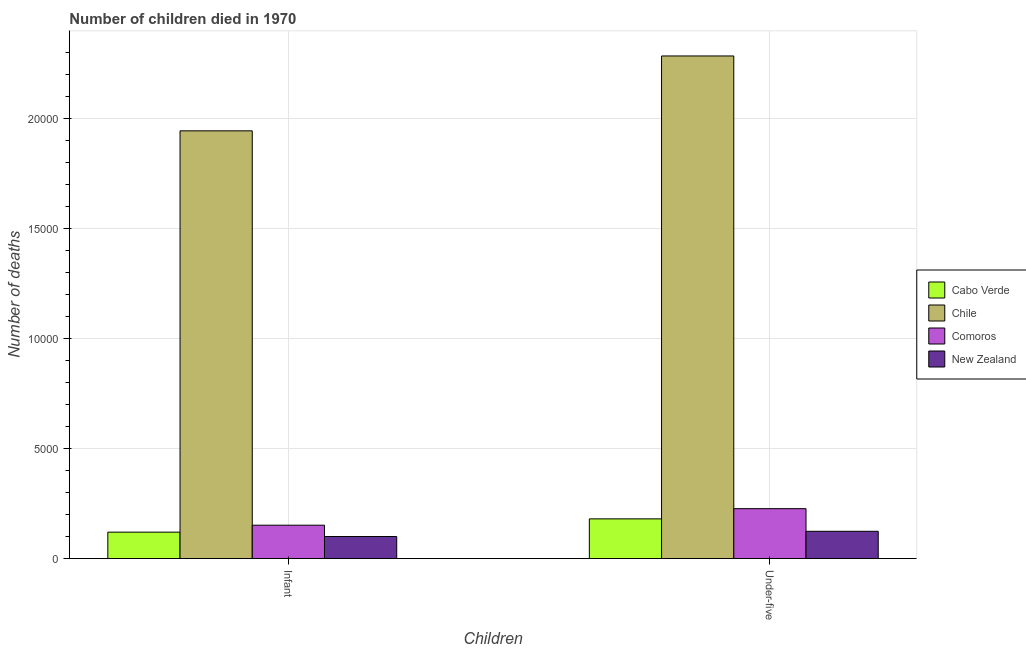How many different coloured bars are there?
Your answer should be very brief. 4. Are the number of bars per tick equal to the number of legend labels?
Make the answer very short. Yes. Are the number of bars on each tick of the X-axis equal?
Ensure brevity in your answer.  Yes. How many bars are there on the 2nd tick from the left?
Offer a very short reply. 4. What is the label of the 2nd group of bars from the left?
Your answer should be compact. Under-five. What is the number of under-five deaths in New Zealand?
Your answer should be compact. 1239. Across all countries, what is the maximum number of under-five deaths?
Your answer should be very brief. 2.28e+04. Across all countries, what is the minimum number of under-five deaths?
Your response must be concise. 1239. In which country was the number of under-five deaths minimum?
Offer a very short reply. New Zealand. What is the total number of under-five deaths in the graph?
Your response must be concise. 2.81e+04. What is the difference between the number of under-five deaths in Cabo Verde and that in Chile?
Make the answer very short. -2.10e+04. What is the difference between the number of under-five deaths in Cabo Verde and the number of infant deaths in Chile?
Your response must be concise. -1.76e+04. What is the average number of under-five deaths per country?
Your answer should be compact. 7034.75. What is the difference between the number of infant deaths and number of under-five deaths in Cabo Verde?
Your answer should be compact. -603. In how many countries, is the number of infant deaths greater than 8000 ?
Your response must be concise. 1. What is the ratio of the number of under-five deaths in Chile to that in Cabo Verde?
Give a very brief answer. 12.66. Is the number of under-five deaths in Chile less than that in Comoros?
Make the answer very short. No. What does the 4th bar from the left in Under-five represents?
Offer a very short reply. New Zealand. What does the 1st bar from the right in Infant represents?
Ensure brevity in your answer.  New Zealand. Are all the bars in the graph horizontal?
Offer a very short reply. No. How many countries are there in the graph?
Offer a terse response. 4. Are the values on the major ticks of Y-axis written in scientific E-notation?
Give a very brief answer. No. Does the graph contain any zero values?
Your response must be concise. No. Does the graph contain grids?
Give a very brief answer. Yes. How are the legend labels stacked?
Provide a succinct answer. Vertical. What is the title of the graph?
Keep it short and to the point. Number of children died in 1970. Does "French Polynesia" appear as one of the legend labels in the graph?
Offer a terse response. No. What is the label or title of the X-axis?
Offer a terse response. Children. What is the label or title of the Y-axis?
Make the answer very short. Number of deaths. What is the Number of deaths in Cabo Verde in Infant?
Make the answer very short. 1200. What is the Number of deaths in Chile in Infant?
Your answer should be very brief. 1.94e+04. What is the Number of deaths in Comoros in Infant?
Offer a terse response. 1516. What is the Number of deaths of New Zealand in Infant?
Offer a very short reply. 1002. What is the Number of deaths of Cabo Verde in Under-five?
Your answer should be compact. 1803. What is the Number of deaths in Chile in Under-five?
Make the answer very short. 2.28e+04. What is the Number of deaths of Comoros in Under-five?
Offer a very short reply. 2267. What is the Number of deaths of New Zealand in Under-five?
Your answer should be very brief. 1239. Across all Children, what is the maximum Number of deaths of Cabo Verde?
Offer a terse response. 1803. Across all Children, what is the maximum Number of deaths in Chile?
Your answer should be very brief. 2.28e+04. Across all Children, what is the maximum Number of deaths of Comoros?
Offer a very short reply. 2267. Across all Children, what is the maximum Number of deaths of New Zealand?
Your answer should be very brief. 1239. Across all Children, what is the minimum Number of deaths in Cabo Verde?
Make the answer very short. 1200. Across all Children, what is the minimum Number of deaths of Chile?
Your answer should be compact. 1.94e+04. Across all Children, what is the minimum Number of deaths in Comoros?
Ensure brevity in your answer.  1516. Across all Children, what is the minimum Number of deaths of New Zealand?
Offer a very short reply. 1002. What is the total Number of deaths in Cabo Verde in the graph?
Give a very brief answer. 3003. What is the total Number of deaths of Chile in the graph?
Offer a terse response. 4.23e+04. What is the total Number of deaths of Comoros in the graph?
Make the answer very short. 3783. What is the total Number of deaths of New Zealand in the graph?
Your response must be concise. 2241. What is the difference between the Number of deaths in Cabo Verde in Infant and that in Under-five?
Your answer should be compact. -603. What is the difference between the Number of deaths in Chile in Infant and that in Under-five?
Provide a succinct answer. -3401. What is the difference between the Number of deaths in Comoros in Infant and that in Under-five?
Offer a very short reply. -751. What is the difference between the Number of deaths of New Zealand in Infant and that in Under-five?
Ensure brevity in your answer.  -237. What is the difference between the Number of deaths in Cabo Verde in Infant and the Number of deaths in Chile in Under-five?
Offer a very short reply. -2.16e+04. What is the difference between the Number of deaths in Cabo Verde in Infant and the Number of deaths in Comoros in Under-five?
Give a very brief answer. -1067. What is the difference between the Number of deaths of Cabo Verde in Infant and the Number of deaths of New Zealand in Under-five?
Your response must be concise. -39. What is the difference between the Number of deaths of Chile in Infant and the Number of deaths of Comoros in Under-five?
Your response must be concise. 1.72e+04. What is the difference between the Number of deaths of Chile in Infant and the Number of deaths of New Zealand in Under-five?
Make the answer very short. 1.82e+04. What is the difference between the Number of deaths in Comoros in Infant and the Number of deaths in New Zealand in Under-five?
Keep it short and to the point. 277. What is the average Number of deaths of Cabo Verde per Children?
Keep it short and to the point. 1501.5. What is the average Number of deaths of Chile per Children?
Make the answer very short. 2.11e+04. What is the average Number of deaths of Comoros per Children?
Offer a very short reply. 1891.5. What is the average Number of deaths of New Zealand per Children?
Your answer should be very brief. 1120.5. What is the difference between the Number of deaths in Cabo Verde and Number of deaths in Chile in Infant?
Make the answer very short. -1.82e+04. What is the difference between the Number of deaths in Cabo Verde and Number of deaths in Comoros in Infant?
Keep it short and to the point. -316. What is the difference between the Number of deaths of Cabo Verde and Number of deaths of New Zealand in Infant?
Your answer should be compact. 198. What is the difference between the Number of deaths in Chile and Number of deaths in Comoros in Infant?
Your answer should be compact. 1.79e+04. What is the difference between the Number of deaths in Chile and Number of deaths in New Zealand in Infant?
Keep it short and to the point. 1.84e+04. What is the difference between the Number of deaths of Comoros and Number of deaths of New Zealand in Infant?
Your answer should be very brief. 514. What is the difference between the Number of deaths in Cabo Verde and Number of deaths in Chile in Under-five?
Your answer should be very brief. -2.10e+04. What is the difference between the Number of deaths in Cabo Verde and Number of deaths in Comoros in Under-five?
Offer a terse response. -464. What is the difference between the Number of deaths of Cabo Verde and Number of deaths of New Zealand in Under-five?
Ensure brevity in your answer.  564. What is the difference between the Number of deaths of Chile and Number of deaths of Comoros in Under-five?
Offer a terse response. 2.06e+04. What is the difference between the Number of deaths in Chile and Number of deaths in New Zealand in Under-five?
Keep it short and to the point. 2.16e+04. What is the difference between the Number of deaths of Comoros and Number of deaths of New Zealand in Under-five?
Provide a short and direct response. 1028. What is the ratio of the Number of deaths in Cabo Verde in Infant to that in Under-five?
Ensure brevity in your answer.  0.67. What is the ratio of the Number of deaths in Chile in Infant to that in Under-five?
Keep it short and to the point. 0.85. What is the ratio of the Number of deaths of Comoros in Infant to that in Under-five?
Your answer should be very brief. 0.67. What is the ratio of the Number of deaths in New Zealand in Infant to that in Under-five?
Offer a very short reply. 0.81. What is the difference between the highest and the second highest Number of deaths in Cabo Verde?
Give a very brief answer. 603. What is the difference between the highest and the second highest Number of deaths of Chile?
Your answer should be very brief. 3401. What is the difference between the highest and the second highest Number of deaths of Comoros?
Give a very brief answer. 751. What is the difference between the highest and the second highest Number of deaths of New Zealand?
Your answer should be very brief. 237. What is the difference between the highest and the lowest Number of deaths in Cabo Verde?
Offer a terse response. 603. What is the difference between the highest and the lowest Number of deaths in Chile?
Give a very brief answer. 3401. What is the difference between the highest and the lowest Number of deaths in Comoros?
Ensure brevity in your answer.  751. What is the difference between the highest and the lowest Number of deaths of New Zealand?
Your answer should be compact. 237. 